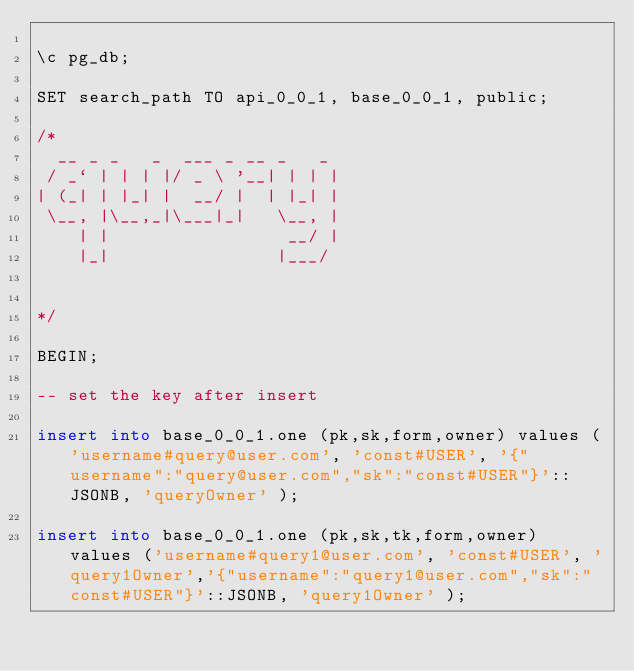Convert code to text. <code><loc_0><loc_0><loc_500><loc_500><_SQL_>
\c pg_db;

SET search_path TO api_0_0_1, base_0_0_1, public;

/*
  __ _ _   _  ___ _ __ _   _
 / _` | | | |/ _ \ '__| | | |
| (_| | |_| |  __/ |  | |_| |
 \__, |\__,_|\___|_|   \__, |
    | |                 __/ |
    |_|                |___/


*/

BEGIN;

-- set the key after insert

insert into base_0_0_1.one (pk,sk,form,owner) values ('username#query@user.com', 'const#USER', '{"username":"query@user.com","sk":"const#USER"}'::JSONB, 'queryOwner' );

insert into base_0_0_1.one (pk,sk,tk,form,owner) values ('username#query1@user.com', 'const#USER', 'query1Owner','{"username":"query1@user.com","sk":"const#USER"}'::JSONB, 'query1Owner' );
</code> 